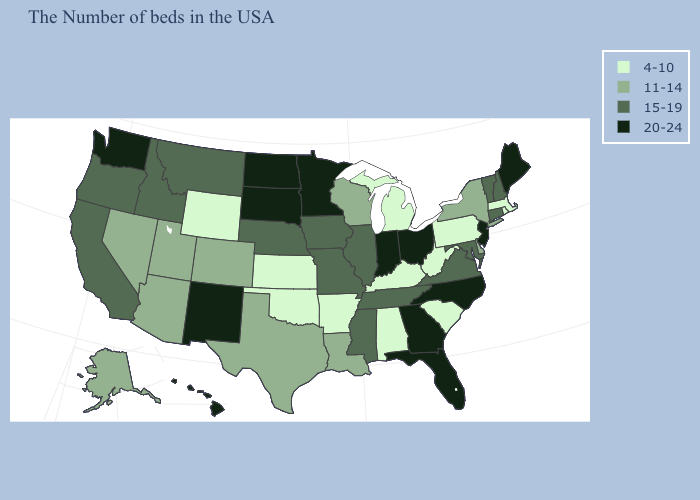Among the states that border Florida , which have the lowest value?
Keep it brief. Alabama. Does the first symbol in the legend represent the smallest category?
Short answer required. Yes. What is the value of Colorado?
Quick response, please. 11-14. Does the map have missing data?
Keep it brief. No. What is the value of Colorado?
Concise answer only. 11-14. Which states hav the highest value in the West?
Be succinct. New Mexico, Washington, Hawaii. Name the states that have a value in the range 20-24?
Be succinct. Maine, New Jersey, North Carolina, Ohio, Florida, Georgia, Indiana, Minnesota, South Dakota, North Dakota, New Mexico, Washington, Hawaii. Which states have the highest value in the USA?
Be succinct. Maine, New Jersey, North Carolina, Ohio, Florida, Georgia, Indiana, Minnesota, South Dakota, North Dakota, New Mexico, Washington, Hawaii. What is the value of New Mexico?
Answer briefly. 20-24. Which states hav the highest value in the South?
Give a very brief answer. North Carolina, Florida, Georgia. Does Maine have the same value as Wyoming?
Quick response, please. No. What is the lowest value in states that border New Jersey?
Short answer required. 4-10. Name the states that have a value in the range 20-24?
Keep it brief. Maine, New Jersey, North Carolina, Ohio, Florida, Georgia, Indiana, Minnesota, South Dakota, North Dakota, New Mexico, Washington, Hawaii. How many symbols are there in the legend?
Give a very brief answer. 4. Does Missouri have a higher value than New York?
Give a very brief answer. Yes. 